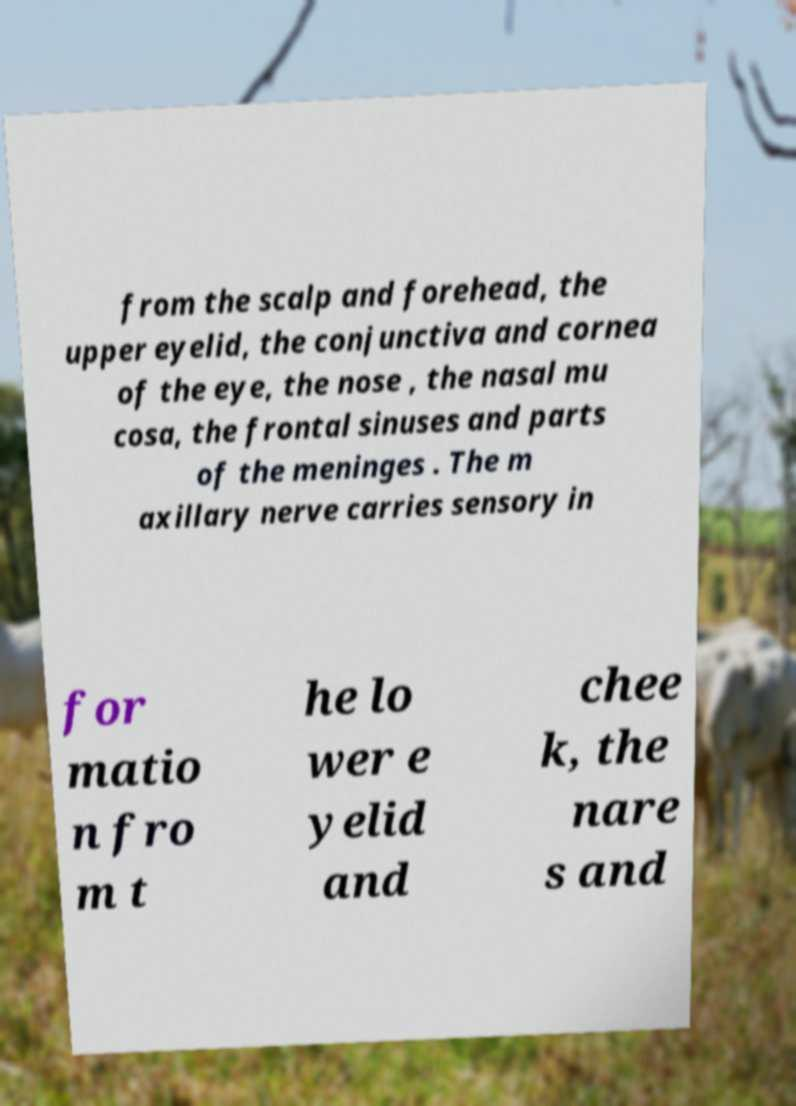Please read and relay the text visible in this image. What does it say? from the scalp and forehead, the upper eyelid, the conjunctiva and cornea of the eye, the nose , the nasal mu cosa, the frontal sinuses and parts of the meninges . The m axillary nerve carries sensory in for matio n fro m t he lo wer e yelid and chee k, the nare s and 